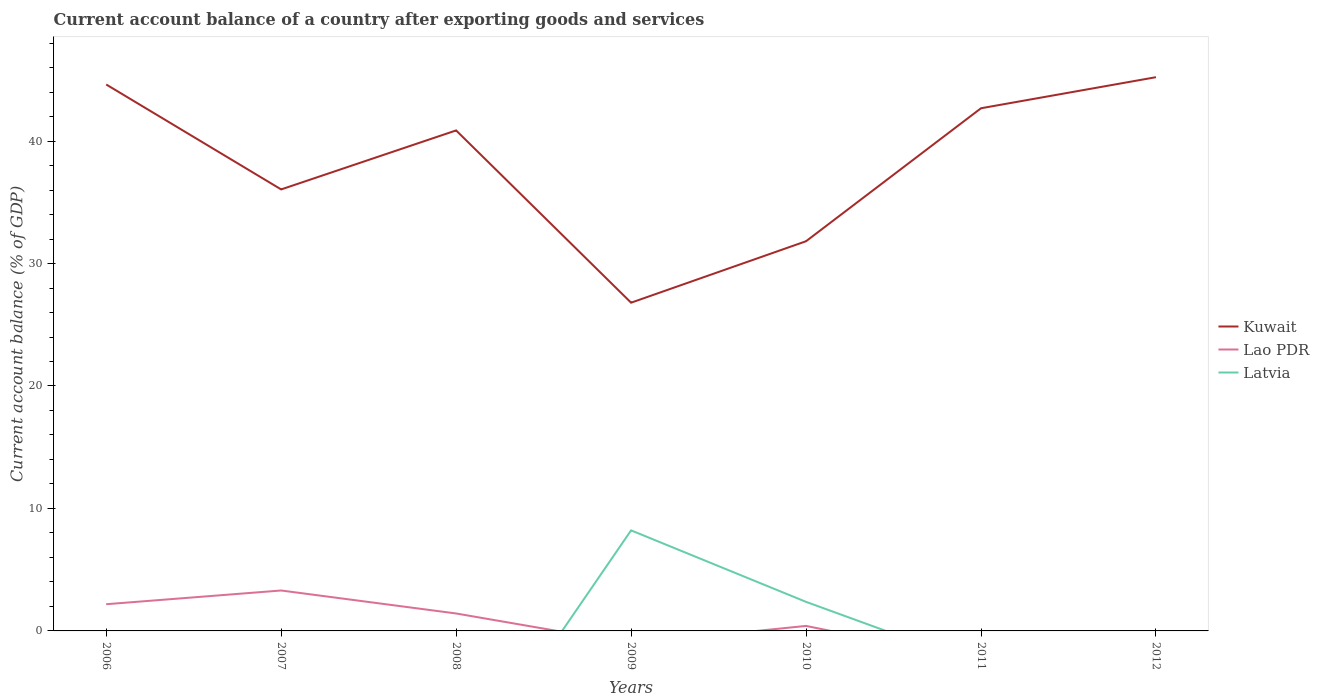How many different coloured lines are there?
Your response must be concise. 3. Across all years, what is the maximum account balance in Kuwait?
Provide a succinct answer. 26.8. What is the total account balance in Kuwait in the graph?
Your answer should be very brief. -6.63. What is the difference between the highest and the second highest account balance in Kuwait?
Offer a terse response. 18.41. Is the account balance in Kuwait strictly greater than the account balance in Lao PDR over the years?
Offer a terse response. No. How many lines are there?
Provide a succinct answer. 3. How many years are there in the graph?
Offer a very short reply. 7. What is the difference between two consecutive major ticks on the Y-axis?
Offer a terse response. 10. Does the graph contain any zero values?
Offer a terse response. Yes. How are the legend labels stacked?
Your answer should be compact. Vertical. What is the title of the graph?
Make the answer very short. Current account balance of a country after exporting goods and services. Does "Dominican Republic" appear as one of the legend labels in the graph?
Give a very brief answer. No. What is the label or title of the Y-axis?
Offer a very short reply. Current account balance (% of GDP). What is the Current account balance (% of GDP) of Kuwait in 2006?
Make the answer very short. 44.62. What is the Current account balance (% of GDP) in Lao PDR in 2006?
Your answer should be very brief. 2.18. What is the Current account balance (% of GDP) in Latvia in 2006?
Give a very brief answer. 0. What is the Current account balance (% of GDP) of Kuwait in 2007?
Give a very brief answer. 36.05. What is the Current account balance (% of GDP) in Lao PDR in 2007?
Your answer should be compact. 3.3. What is the Current account balance (% of GDP) in Kuwait in 2008?
Your answer should be compact. 40.87. What is the Current account balance (% of GDP) of Lao PDR in 2008?
Your response must be concise. 1.42. What is the Current account balance (% of GDP) in Kuwait in 2009?
Your response must be concise. 26.8. What is the Current account balance (% of GDP) in Latvia in 2009?
Provide a short and direct response. 8.21. What is the Current account balance (% of GDP) of Kuwait in 2010?
Offer a very short reply. 31.82. What is the Current account balance (% of GDP) in Lao PDR in 2010?
Make the answer very short. 0.41. What is the Current account balance (% of GDP) in Latvia in 2010?
Offer a very short reply. 2.37. What is the Current account balance (% of GDP) in Kuwait in 2011?
Offer a terse response. 42.68. What is the Current account balance (% of GDP) in Lao PDR in 2011?
Your answer should be compact. 0. What is the Current account balance (% of GDP) of Latvia in 2011?
Give a very brief answer. 0. What is the Current account balance (% of GDP) of Kuwait in 2012?
Ensure brevity in your answer.  45.22. Across all years, what is the maximum Current account balance (% of GDP) in Kuwait?
Offer a terse response. 45.22. Across all years, what is the maximum Current account balance (% of GDP) in Lao PDR?
Ensure brevity in your answer.  3.3. Across all years, what is the maximum Current account balance (% of GDP) in Latvia?
Offer a very short reply. 8.21. Across all years, what is the minimum Current account balance (% of GDP) of Kuwait?
Offer a terse response. 26.8. Across all years, what is the minimum Current account balance (% of GDP) of Lao PDR?
Offer a terse response. 0. What is the total Current account balance (% of GDP) in Kuwait in the graph?
Your answer should be compact. 268.06. What is the total Current account balance (% of GDP) of Lao PDR in the graph?
Give a very brief answer. 7.31. What is the total Current account balance (% of GDP) in Latvia in the graph?
Your answer should be very brief. 10.58. What is the difference between the Current account balance (% of GDP) in Kuwait in 2006 and that in 2007?
Give a very brief answer. 8.57. What is the difference between the Current account balance (% of GDP) in Lao PDR in 2006 and that in 2007?
Your response must be concise. -1.12. What is the difference between the Current account balance (% of GDP) in Kuwait in 2006 and that in 2008?
Your answer should be very brief. 3.75. What is the difference between the Current account balance (% of GDP) of Lao PDR in 2006 and that in 2008?
Make the answer very short. 0.76. What is the difference between the Current account balance (% of GDP) in Kuwait in 2006 and that in 2009?
Ensure brevity in your answer.  17.82. What is the difference between the Current account balance (% of GDP) in Kuwait in 2006 and that in 2010?
Offer a terse response. 12.8. What is the difference between the Current account balance (% of GDP) of Lao PDR in 2006 and that in 2010?
Give a very brief answer. 1.77. What is the difference between the Current account balance (% of GDP) of Kuwait in 2006 and that in 2011?
Keep it short and to the point. 1.94. What is the difference between the Current account balance (% of GDP) of Kuwait in 2006 and that in 2012?
Make the answer very short. -0.6. What is the difference between the Current account balance (% of GDP) in Kuwait in 2007 and that in 2008?
Your answer should be very brief. -4.82. What is the difference between the Current account balance (% of GDP) in Lao PDR in 2007 and that in 2008?
Keep it short and to the point. 1.88. What is the difference between the Current account balance (% of GDP) in Kuwait in 2007 and that in 2009?
Offer a very short reply. 9.25. What is the difference between the Current account balance (% of GDP) in Kuwait in 2007 and that in 2010?
Keep it short and to the point. 4.23. What is the difference between the Current account balance (% of GDP) of Lao PDR in 2007 and that in 2010?
Your answer should be compact. 2.89. What is the difference between the Current account balance (% of GDP) in Kuwait in 2007 and that in 2011?
Keep it short and to the point. -6.63. What is the difference between the Current account balance (% of GDP) of Kuwait in 2007 and that in 2012?
Ensure brevity in your answer.  -9.16. What is the difference between the Current account balance (% of GDP) of Kuwait in 2008 and that in 2009?
Your answer should be compact. 14.07. What is the difference between the Current account balance (% of GDP) in Kuwait in 2008 and that in 2010?
Offer a terse response. 9.05. What is the difference between the Current account balance (% of GDP) of Lao PDR in 2008 and that in 2010?
Offer a very short reply. 1.02. What is the difference between the Current account balance (% of GDP) of Kuwait in 2008 and that in 2011?
Keep it short and to the point. -1.81. What is the difference between the Current account balance (% of GDP) in Kuwait in 2008 and that in 2012?
Your answer should be very brief. -4.35. What is the difference between the Current account balance (% of GDP) of Kuwait in 2009 and that in 2010?
Offer a terse response. -5.02. What is the difference between the Current account balance (% of GDP) of Latvia in 2009 and that in 2010?
Your answer should be compact. 5.84. What is the difference between the Current account balance (% of GDP) in Kuwait in 2009 and that in 2011?
Ensure brevity in your answer.  -15.88. What is the difference between the Current account balance (% of GDP) in Kuwait in 2009 and that in 2012?
Your response must be concise. -18.41. What is the difference between the Current account balance (% of GDP) in Kuwait in 2010 and that in 2011?
Your answer should be very brief. -10.86. What is the difference between the Current account balance (% of GDP) in Kuwait in 2010 and that in 2012?
Provide a succinct answer. -13.4. What is the difference between the Current account balance (% of GDP) of Kuwait in 2011 and that in 2012?
Provide a short and direct response. -2.54. What is the difference between the Current account balance (% of GDP) of Kuwait in 2006 and the Current account balance (% of GDP) of Lao PDR in 2007?
Offer a very short reply. 41.32. What is the difference between the Current account balance (% of GDP) of Kuwait in 2006 and the Current account balance (% of GDP) of Lao PDR in 2008?
Ensure brevity in your answer.  43.2. What is the difference between the Current account balance (% of GDP) in Kuwait in 2006 and the Current account balance (% of GDP) in Latvia in 2009?
Provide a short and direct response. 36.41. What is the difference between the Current account balance (% of GDP) of Lao PDR in 2006 and the Current account balance (% of GDP) of Latvia in 2009?
Provide a succinct answer. -6.03. What is the difference between the Current account balance (% of GDP) in Kuwait in 2006 and the Current account balance (% of GDP) in Lao PDR in 2010?
Keep it short and to the point. 44.21. What is the difference between the Current account balance (% of GDP) of Kuwait in 2006 and the Current account balance (% of GDP) of Latvia in 2010?
Offer a very short reply. 42.25. What is the difference between the Current account balance (% of GDP) in Lao PDR in 2006 and the Current account balance (% of GDP) in Latvia in 2010?
Offer a terse response. -0.19. What is the difference between the Current account balance (% of GDP) in Kuwait in 2007 and the Current account balance (% of GDP) in Lao PDR in 2008?
Your answer should be compact. 34.63. What is the difference between the Current account balance (% of GDP) of Kuwait in 2007 and the Current account balance (% of GDP) of Latvia in 2009?
Give a very brief answer. 27.84. What is the difference between the Current account balance (% of GDP) of Lao PDR in 2007 and the Current account balance (% of GDP) of Latvia in 2009?
Keep it short and to the point. -4.91. What is the difference between the Current account balance (% of GDP) of Kuwait in 2007 and the Current account balance (% of GDP) of Lao PDR in 2010?
Your answer should be compact. 35.64. What is the difference between the Current account balance (% of GDP) of Kuwait in 2007 and the Current account balance (% of GDP) of Latvia in 2010?
Give a very brief answer. 33.68. What is the difference between the Current account balance (% of GDP) in Lao PDR in 2007 and the Current account balance (% of GDP) in Latvia in 2010?
Give a very brief answer. 0.93. What is the difference between the Current account balance (% of GDP) of Kuwait in 2008 and the Current account balance (% of GDP) of Latvia in 2009?
Offer a terse response. 32.66. What is the difference between the Current account balance (% of GDP) in Lao PDR in 2008 and the Current account balance (% of GDP) in Latvia in 2009?
Provide a short and direct response. -6.79. What is the difference between the Current account balance (% of GDP) in Kuwait in 2008 and the Current account balance (% of GDP) in Lao PDR in 2010?
Keep it short and to the point. 40.46. What is the difference between the Current account balance (% of GDP) of Kuwait in 2008 and the Current account balance (% of GDP) of Latvia in 2010?
Provide a succinct answer. 38.5. What is the difference between the Current account balance (% of GDP) in Lao PDR in 2008 and the Current account balance (% of GDP) in Latvia in 2010?
Provide a short and direct response. -0.95. What is the difference between the Current account balance (% of GDP) in Kuwait in 2009 and the Current account balance (% of GDP) in Lao PDR in 2010?
Keep it short and to the point. 26.39. What is the difference between the Current account balance (% of GDP) in Kuwait in 2009 and the Current account balance (% of GDP) in Latvia in 2010?
Offer a very short reply. 24.43. What is the average Current account balance (% of GDP) in Kuwait per year?
Your answer should be compact. 38.29. What is the average Current account balance (% of GDP) of Lao PDR per year?
Your answer should be compact. 1.04. What is the average Current account balance (% of GDP) of Latvia per year?
Your answer should be very brief. 1.51. In the year 2006, what is the difference between the Current account balance (% of GDP) of Kuwait and Current account balance (% of GDP) of Lao PDR?
Give a very brief answer. 42.44. In the year 2007, what is the difference between the Current account balance (% of GDP) of Kuwait and Current account balance (% of GDP) of Lao PDR?
Give a very brief answer. 32.75. In the year 2008, what is the difference between the Current account balance (% of GDP) of Kuwait and Current account balance (% of GDP) of Lao PDR?
Your response must be concise. 39.44. In the year 2009, what is the difference between the Current account balance (% of GDP) of Kuwait and Current account balance (% of GDP) of Latvia?
Provide a succinct answer. 18.59. In the year 2010, what is the difference between the Current account balance (% of GDP) of Kuwait and Current account balance (% of GDP) of Lao PDR?
Offer a very short reply. 31.41. In the year 2010, what is the difference between the Current account balance (% of GDP) of Kuwait and Current account balance (% of GDP) of Latvia?
Keep it short and to the point. 29.45. In the year 2010, what is the difference between the Current account balance (% of GDP) in Lao PDR and Current account balance (% of GDP) in Latvia?
Give a very brief answer. -1.96. What is the ratio of the Current account balance (% of GDP) in Kuwait in 2006 to that in 2007?
Give a very brief answer. 1.24. What is the ratio of the Current account balance (% of GDP) of Lao PDR in 2006 to that in 2007?
Provide a short and direct response. 0.66. What is the ratio of the Current account balance (% of GDP) of Kuwait in 2006 to that in 2008?
Offer a terse response. 1.09. What is the ratio of the Current account balance (% of GDP) in Lao PDR in 2006 to that in 2008?
Offer a very short reply. 1.53. What is the ratio of the Current account balance (% of GDP) in Kuwait in 2006 to that in 2009?
Offer a very short reply. 1.66. What is the ratio of the Current account balance (% of GDP) in Kuwait in 2006 to that in 2010?
Your answer should be compact. 1.4. What is the ratio of the Current account balance (% of GDP) of Lao PDR in 2006 to that in 2010?
Your answer should be very brief. 5.34. What is the ratio of the Current account balance (% of GDP) in Kuwait in 2006 to that in 2011?
Keep it short and to the point. 1.05. What is the ratio of the Current account balance (% of GDP) in Kuwait in 2007 to that in 2008?
Ensure brevity in your answer.  0.88. What is the ratio of the Current account balance (% of GDP) in Lao PDR in 2007 to that in 2008?
Your answer should be compact. 2.32. What is the ratio of the Current account balance (% of GDP) of Kuwait in 2007 to that in 2009?
Give a very brief answer. 1.35. What is the ratio of the Current account balance (% of GDP) in Kuwait in 2007 to that in 2010?
Your answer should be very brief. 1.13. What is the ratio of the Current account balance (% of GDP) of Lao PDR in 2007 to that in 2010?
Give a very brief answer. 8.09. What is the ratio of the Current account balance (% of GDP) of Kuwait in 2007 to that in 2011?
Give a very brief answer. 0.84. What is the ratio of the Current account balance (% of GDP) in Kuwait in 2007 to that in 2012?
Your response must be concise. 0.8. What is the ratio of the Current account balance (% of GDP) of Kuwait in 2008 to that in 2009?
Make the answer very short. 1.52. What is the ratio of the Current account balance (% of GDP) of Kuwait in 2008 to that in 2010?
Provide a succinct answer. 1.28. What is the ratio of the Current account balance (% of GDP) of Lao PDR in 2008 to that in 2010?
Keep it short and to the point. 3.49. What is the ratio of the Current account balance (% of GDP) of Kuwait in 2008 to that in 2011?
Your answer should be compact. 0.96. What is the ratio of the Current account balance (% of GDP) in Kuwait in 2008 to that in 2012?
Provide a short and direct response. 0.9. What is the ratio of the Current account balance (% of GDP) of Kuwait in 2009 to that in 2010?
Your answer should be very brief. 0.84. What is the ratio of the Current account balance (% of GDP) in Latvia in 2009 to that in 2010?
Provide a short and direct response. 3.46. What is the ratio of the Current account balance (% of GDP) in Kuwait in 2009 to that in 2011?
Your response must be concise. 0.63. What is the ratio of the Current account balance (% of GDP) in Kuwait in 2009 to that in 2012?
Keep it short and to the point. 0.59. What is the ratio of the Current account balance (% of GDP) in Kuwait in 2010 to that in 2011?
Keep it short and to the point. 0.75. What is the ratio of the Current account balance (% of GDP) in Kuwait in 2010 to that in 2012?
Provide a short and direct response. 0.7. What is the ratio of the Current account balance (% of GDP) of Kuwait in 2011 to that in 2012?
Provide a succinct answer. 0.94. What is the difference between the highest and the second highest Current account balance (% of GDP) in Kuwait?
Offer a terse response. 0.6. What is the difference between the highest and the second highest Current account balance (% of GDP) of Lao PDR?
Your answer should be compact. 1.12. What is the difference between the highest and the lowest Current account balance (% of GDP) of Kuwait?
Ensure brevity in your answer.  18.41. What is the difference between the highest and the lowest Current account balance (% of GDP) of Lao PDR?
Your answer should be compact. 3.3. What is the difference between the highest and the lowest Current account balance (% of GDP) in Latvia?
Give a very brief answer. 8.21. 